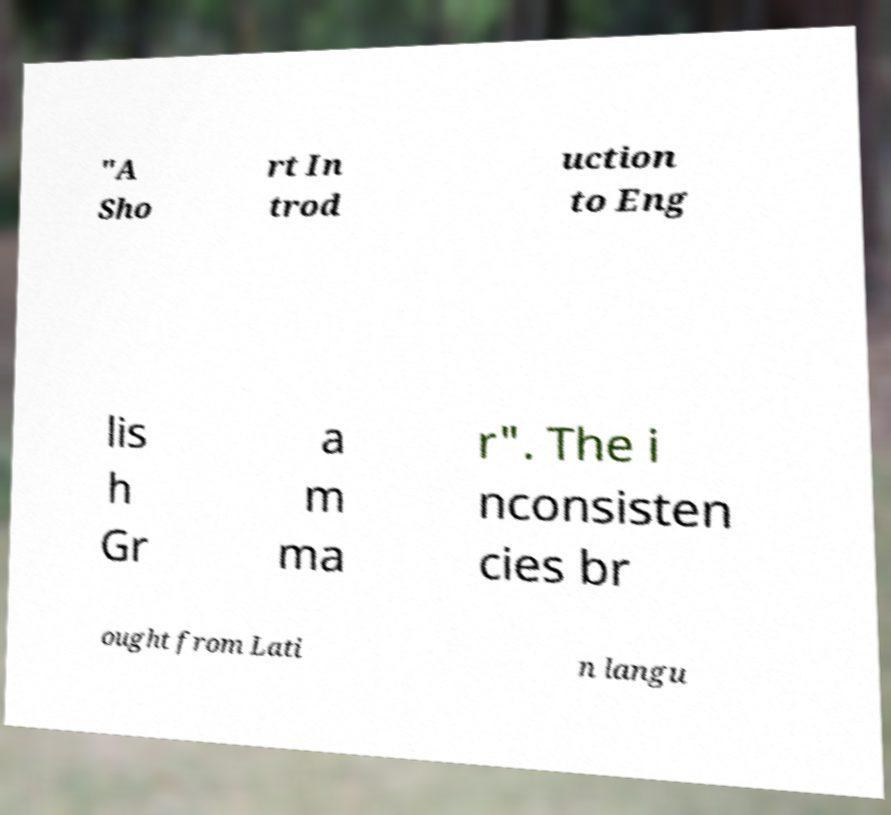Could you assist in decoding the text presented in this image and type it out clearly? "A Sho rt In trod uction to Eng lis h Gr a m ma r". The i nconsisten cies br ought from Lati n langu 